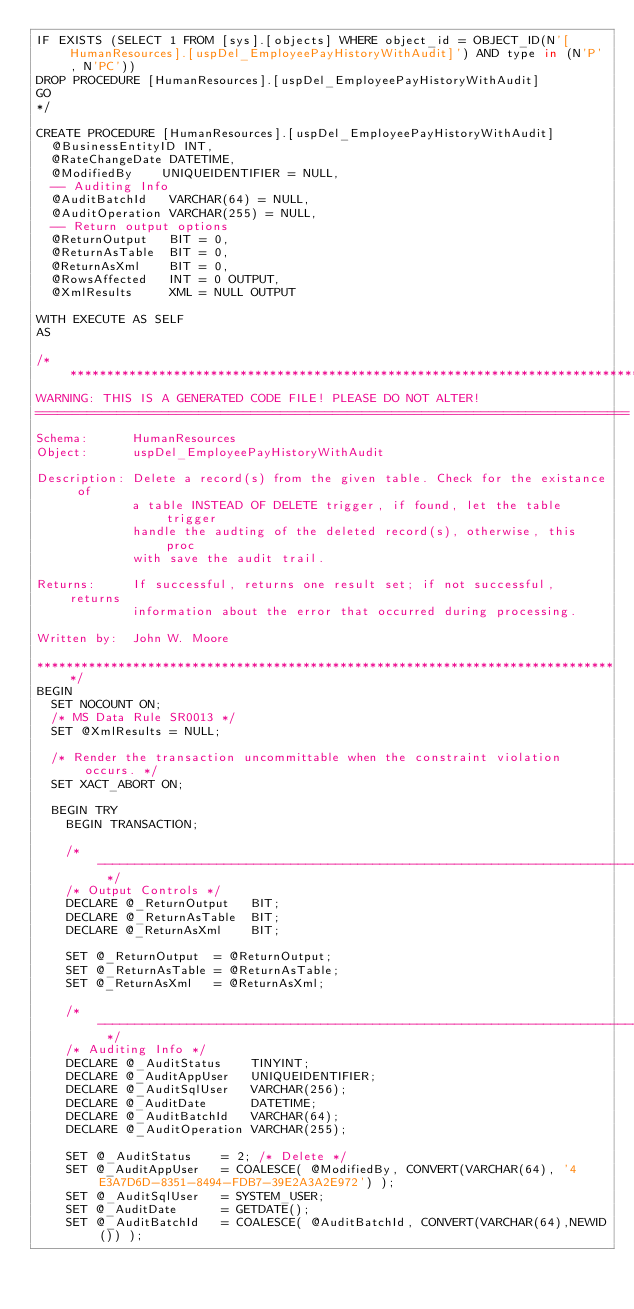Convert code to text. <code><loc_0><loc_0><loc_500><loc_500><_SQL_>IF EXISTS (SELECT 1 FROM [sys].[objects] WHERE object_id = OBJECT_ID(N'[HumanResources].[uspDel_EmployeePayHistoryWithAudit]') AND type in (N'P', N'PC'))
DROP PROCEDURE [HumanResources].[uspDel_EmployeePayHistoryWithAudit]
GO
*/

CREATE PROCEDURE [HumanResources].[uspDel_EmployeePayHistoryWithAudit]
  @BusinessEntityID INT,
  @RateChangeDate DATETIME,
  @ModifiedBy    UNIQUEIDENTIFIER = NULL,
  -- Auditing Info
  @AuditBatchId   VARCHAR(64) = NULL,
  @AuditOperation VARCHAR(255) = NULL,
  -- Return output options
  @ReturnOutput   BIT = 0,
  @ReturnAsTable  BIT = 0,
  @ReturnAsXml    BIT = 0,
  @RowsAffected   INT = 0 OUTPUT,
  @XmlResults     XML = NULL OUTPUT

WITH EXECUTE AS SELF
AS

/*******************************************************************************
WARNING: THIS IS A GENERATED CODE FILE! PLEASE DO NOT ALTER!
================================================================================
Schema:      HumanResources
Object:      uspDel_EmployeePayHistoryWithAudit

Description: Delete a record(s) from the given table. Check for the existance of
             a table INSTEAD OF DELETE trigger, if found, let the table trigger
             handle the audting of the deleted record(s), otherwise, this proc
             with save the audit trail.

Returns:     If successful, returns one result set; if not successful, returns
             information about the error that occurred during processing.

Written by:  John W. Moore

*******************************************************************************/
BEGIN
  SET NOCOUNT ON;
  /* MS Data Rule SR0013 */
  SET @XmlResults = NULL;

  /* Render the transaction uncommittable when the constraint violation occurs. */
  SET XACT_ABORT ON;

  BEGIN TRY
    BEGIN TRANSACTION;

    /* ------------------------------------------------------------------------- */
    /* Output Controls */
    DECLARE @_ReturnOutput   BIT;
    DECLARE @_ReturnAsTable  BIT;
    DECLARE @_ReturnAsXml    BIT;

    SET @_ReturnOutput  = @ReturnOutput;
    SET @_ReturnAsTable = @ReturnAsTable;
    SET @_ReturnAsXml   = @ReturnAsXml;

    /* ------------------------------------------------------------------------- */
    /* Auditing Info */
    DECLARE @_AuditStatus    TINYINT;
    DECLARE @_AuditAppUser   UNIQUEIDENTIFIER;
    DECLARE @_AuditSqlUser   VARCHAR(256);
    DECLARE @_AuditDate      DATETIME;
    DECLARE @_AuditBatchId   VARCHAR(64);
    DECLARE @_AuditOperation VARCHAR(255);

    SET @_AuditStatus    = 2; /* Delete */
    SET @_AuditAppUser   = COALESCE( @ModifiedBy, CONVERT(VARCHAR(64), '4E3A7D6D-8351-8494-FDB7-39E2A3A2E972') );
    SET @_AuditSqlUser   = SYSTEM_USER;
    SET @_AuditDate      = GETDATE();
    SET @_AuditBatchId   = COALESCE( @AuditBatchId, CONVERT(VARCHAR(64),NEWID()) );</code> 